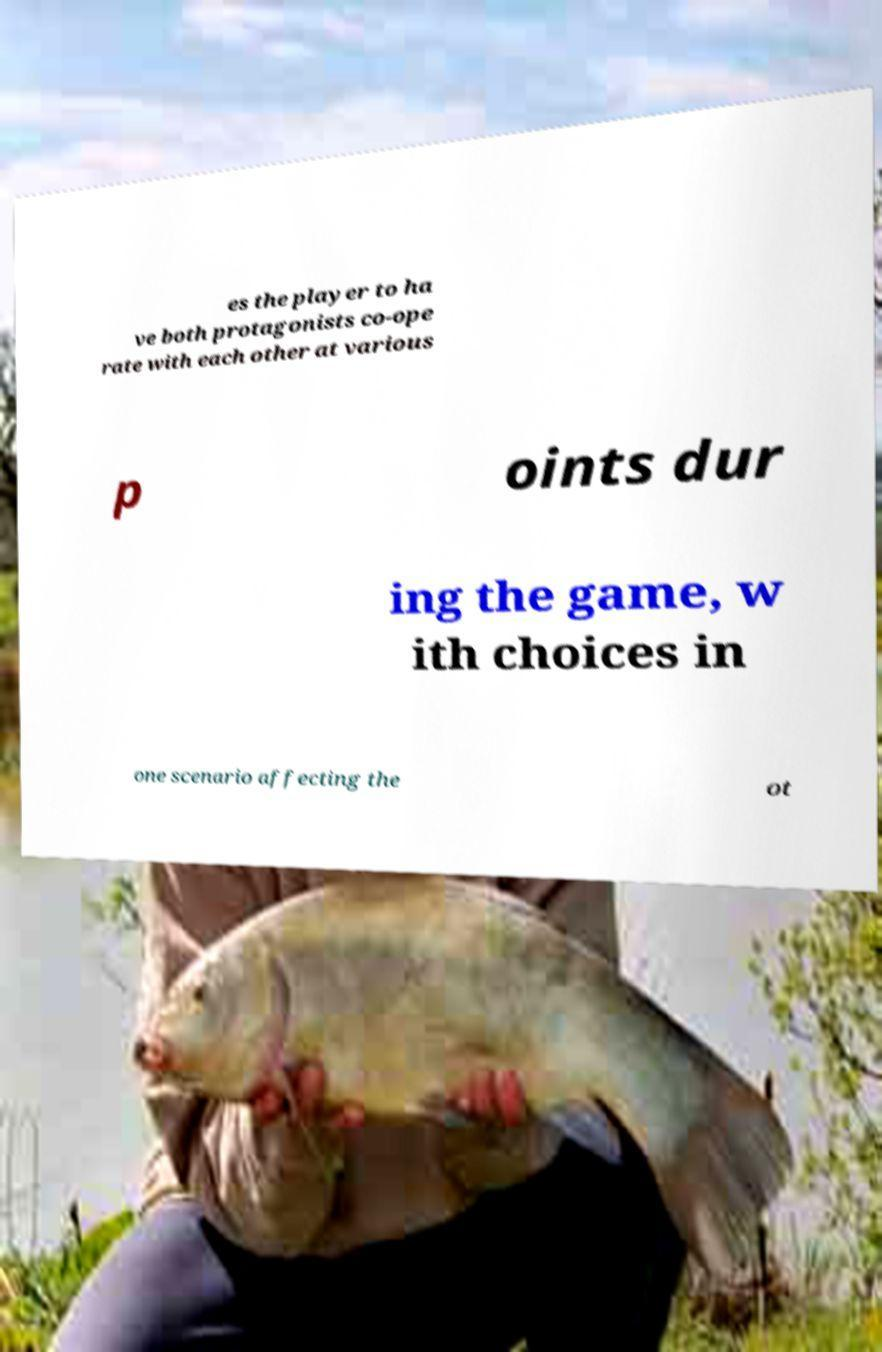There's text embedded in this image that I need extracted. Can you transcribe it verbatim? es the player to ha ve both protagonists co-ope rate with each other at various p oints dur ing the game, w ith choices in one scenario affecting the ot 